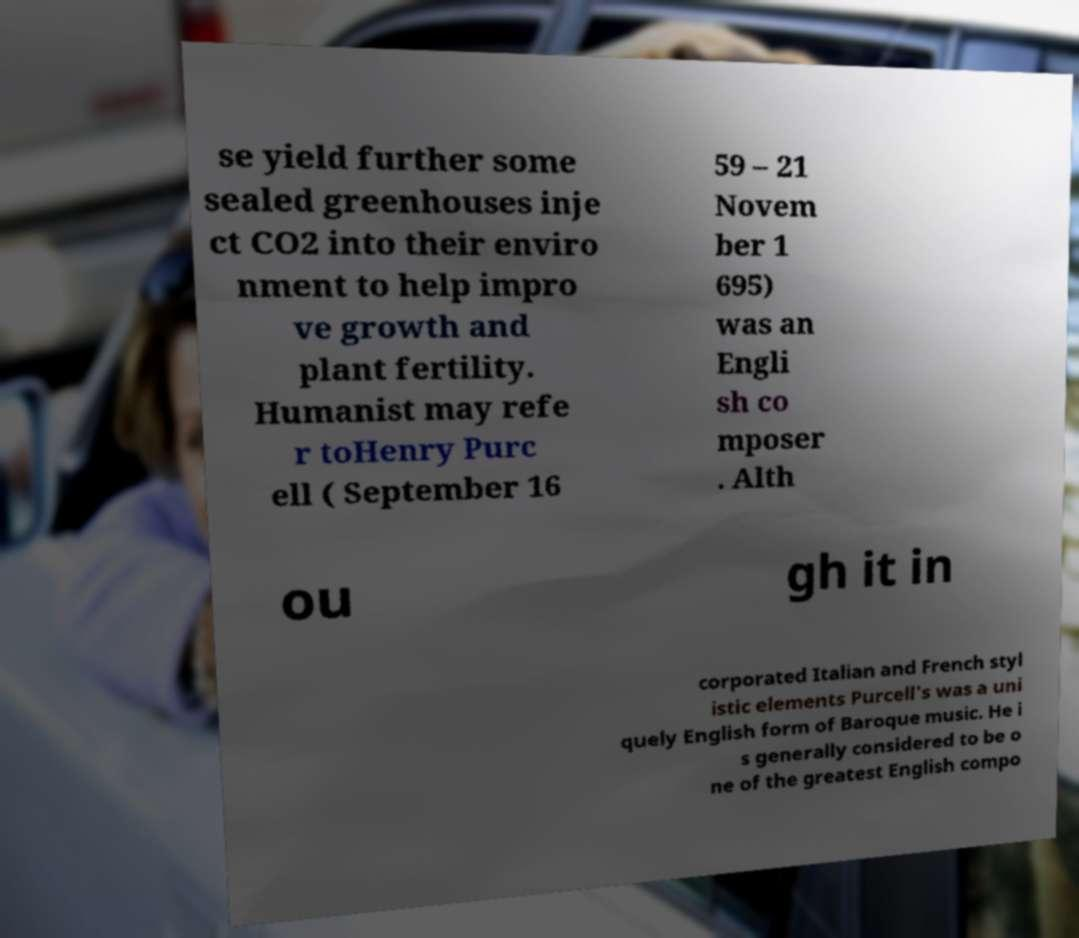Can you read and provide the text displayed in the image?This photo seems to have some interesting text. Can you extract and type it out for me? se yield further some sealed greenhouses inje ct CO2 into their enviro nment to help impro ve growth and plant fertility. Humanist may refe r toHenry Purc ell ( September 16 59 – 21 Novem ber 1 695) was an Engli sh co mposer . Alth ou gh it in corporated Italian and French styl istic elements Purcell's was a uni quely English form of Baroque music. He i s generally considered to be o ne of the greatest English compo 